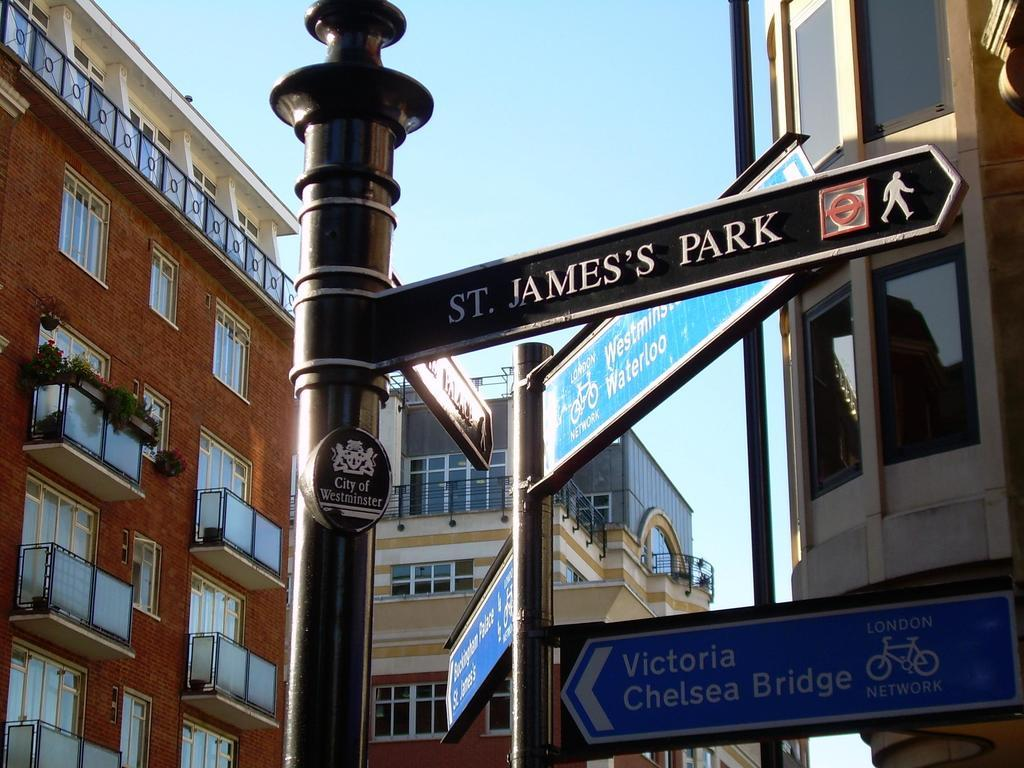What is located in the foreground of the picture? There is a name sign board in the foreground of the picture. What is associated with the sign board? There are poles associated with the sign board. What can be seen in the background of the picture? There are buildings and glass windows visible in the background. What is visible in the sky? There are clouds in the sky. What type of prose is being written on the sign board in the image? There is no prose being written on the sign board in the image; it is a name sign board with no text visible. What is the tax rate for the buildings in the background of the image? There is no information about tax rates in the image; it only shows a name sign board and buildings in the background. 